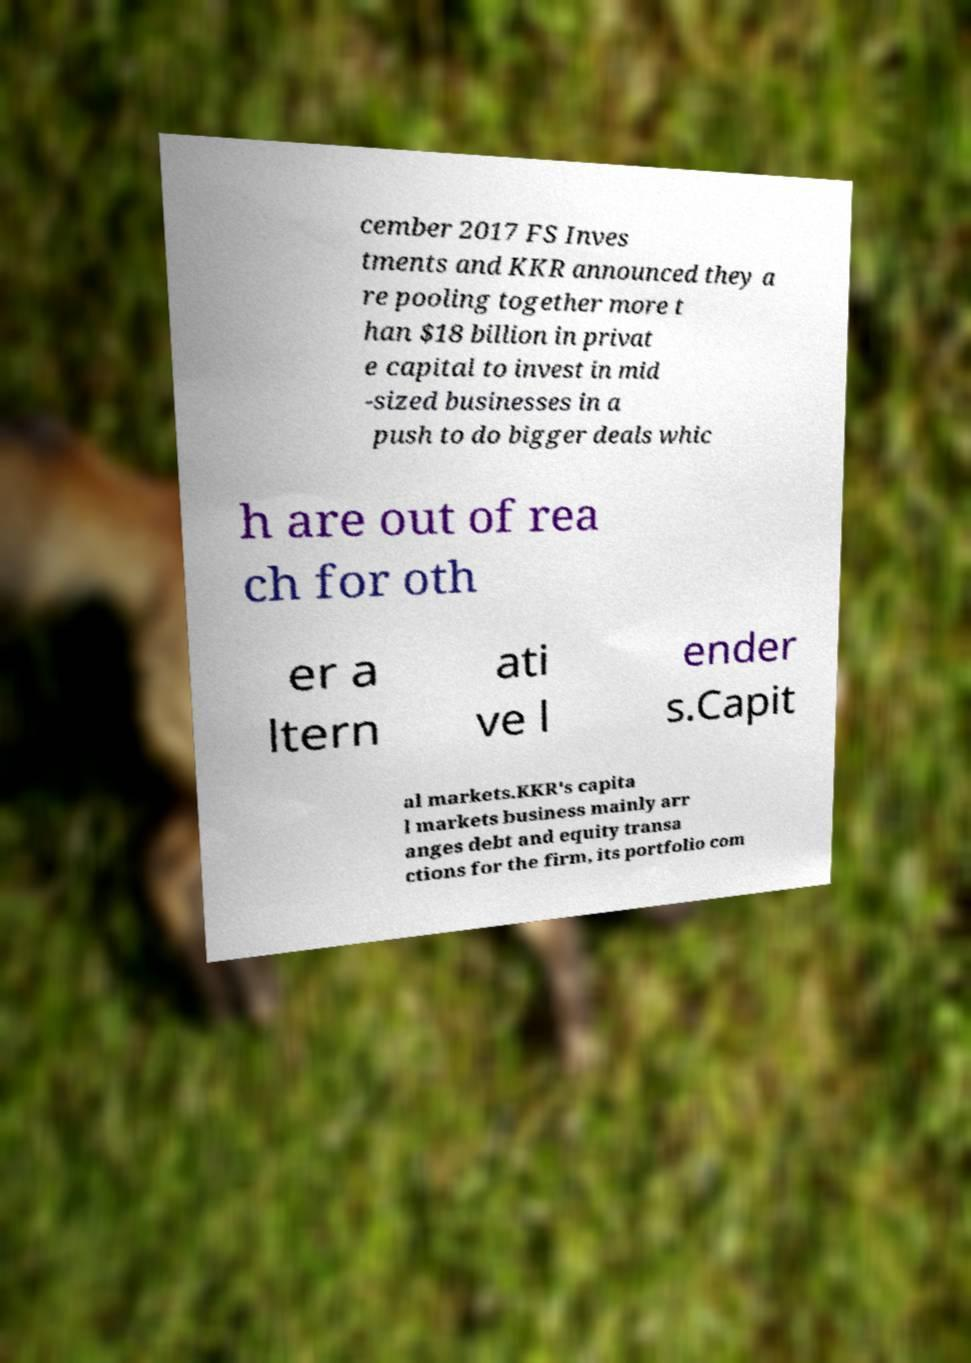There's text embedded in this image that I need extracted. Can you transcribe it verbatim? cember 2017 FS Inves tments and KKR announced they a re pooling together more t han $18 billion in privat e capital to invest in mid -sized businesses in a push to do bigger deals whic h are out of rea ch for oth er a ltern ati ve l ender s.Capit al markets.KKR's capita l markets business mainly arr anges debt and equity transa ctions for the firm, its portfolio com 